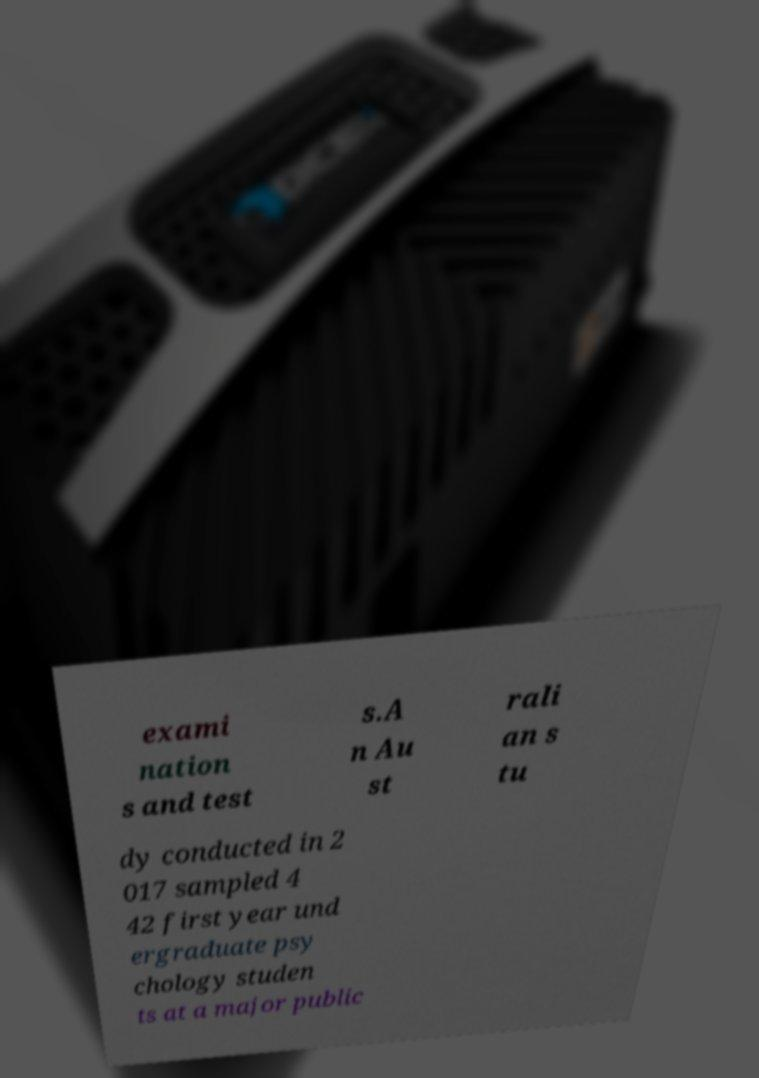For documentation purposes, I need the text within this image transcribed. Could you provide that? exami nation s and test s.A n Au st rali an s tu dy conducted in 2 017 sampled 4 42 first year und ergraduate psy chology studen ts at a major public 